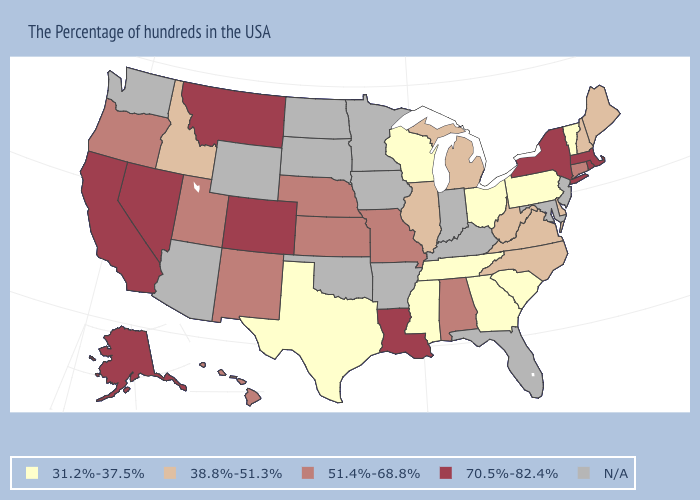Among the states that border Illinois , does Wisconsin have the lowest value?
Concise answer only. Yes. Name the states that have a value in the range N/A?
Concise answer only. New Jersey, Maryland, Florida, Kentucky, Indiana, Arkansas, Minnesota, Iowa, Oklahoma, South Dakota, North Dakota, Wyoming, Arizona, Washington. Which states have the lowest value in the West?
Write a very short answer. Idaho. Which states have the highest value in the USA?
Concise answer only. Massachusetts, Rhode Island, New York, Louisiana, Colorado, Montana, Nevada, California, Alaska. What is the value of Connecticut?
Be succinct. 51.4%-68.8%. Does Pennsylvania have the lowest value in the USA?
Short answer required. Yes. What is the lowest value in states that border Arkansas?
Quick response, please. 31.2%-37.5%. Which states have the lowest value in the South?
Concise answer only. South Carolina, Georgia, Tennessee, Mississippi, Texas. What is the highest value in the USA?
Be succinct. 70.5%-82.4%. Among the states that border New Hampshire , does Vermont have the highest value?
Answer briefly. No. What is the highest value in the South ?
Write a very short answer. 70.5%-82.4%. What is the value of West Virginia?
Give a very brief answer. 38.8%-51.3%. Does the map have missing data?
Quick response, please. Yes. Does Ohio have the lowest value in the USA?
Answer briefly. Yes. 